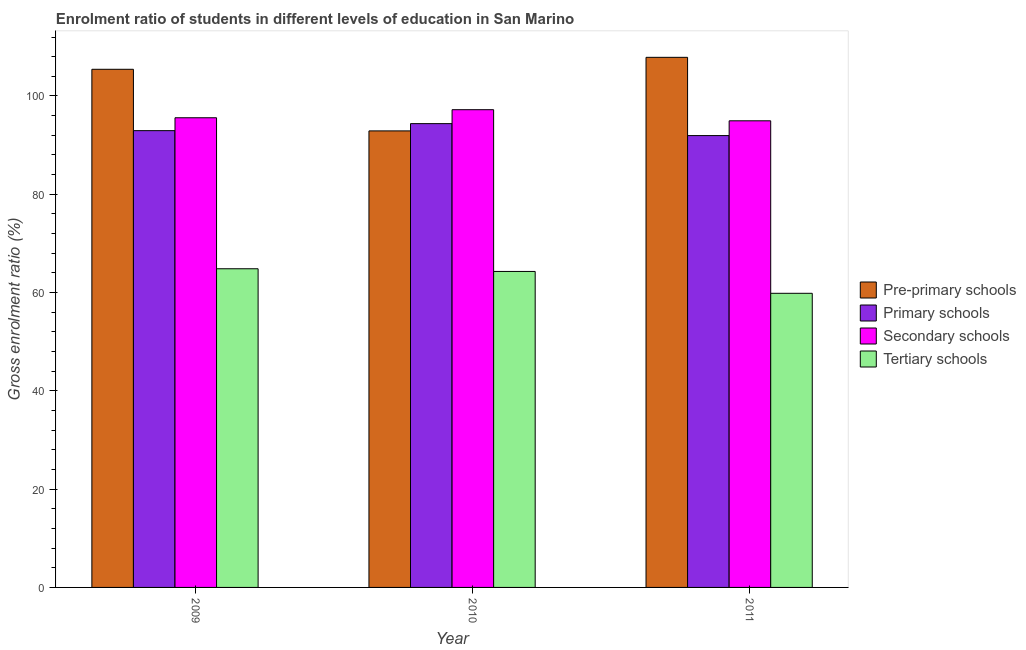How many different coloured bars are there?
Ensure brevity in your answer.  4. How many groups of bars are there?
Ensure brevity in your answer.  3. Are the number of bars per tick equal to the number of legend labels?
Offer a very short reply. Yes. Are the number of bars on each tick of the X-axis equal?
Keep it short and to the point. Yes. How many bars are there on the 2nd tick from the left?
Offer a very short reply. 4. How many bars are there on the 1st tick from the right?
Ensure brevity in your answer.  4. In how many cases, is the number of bars for a given year not equal to the number of legend labels?
Give a very brief answer. 0. What is the gross enrolment ratio in pre-primary schools in 2011?
Make the answer very short. 107.87. Across all years, what is the maximum gross enrolment ratio in tertiary schools?
Offer a terse response. 64.84. Across all years, what is the minimum gross enrolment ratio in primary schools?
Your answer should be very brief. 91.94. What is the total gross enrolment ratio in pre-primary schools in the graph?
Provide a succinct answer. 306.19. What is the difference between the gross enrolment ratio in tertiary schools in 2010 and that in 2011?
Your answer should be very brief. 4.45. What is the difference between the gross enrolment ratio in tertiary schools in 2009 and the gross enrolment ratio in primary schools in 2011?
Your answer should be very brief. 5. What is the average gross enrolment ratio in primary schools per year?
Give a very brief answer. 93.09. What is the ratio of the gross enrolment ratio in tertiary schools in 2010 to that in 2011?
Ensure brevity in your answer.  1.07. Is the difference between the gross enrolment ratio in pre-primary schools in 2009 and 2011 greater than the difference between the gross enrolment ratio in tertiary schools in 2009 and 2011?
Keep it short and to the point. No. What is the difference between the highest and the second highest gross enrolment ratio in pre-primary schools?
Make the answer very short. 2.43. What is the difference between the highest and the lowest gross enrolment ratio in secondary schools?
Your answer should be compact. 2.26. In how many years, is the gross enrolment ratio in pre-primary schools greater than the average gross enrolment ratio in pre-primary schools taken over all years?
Provide a short and direct response. 2. What does the 4th bar from the left in 2011 represents?
Provide a short and direct response. Tertiary schools. What does the 2nd bar from the right in 2011 represents?
Offer a very short reply. Secondary schools. How many bars are there?
Offer a terse response. 12. How many years are there in the graph?
Make the answer very short. 3. Are the values on the major ticks of Y-axis written in scientific E-notation?
Give a very brief answer. No. Where does the legend appear in the graph?
Ensure brevity in your answer.  Center right. What is the title of the graph?
Keep it short and to the point. Enrolment ratio of students in different levels of education in San Marino. Does "UNDP" appear as one of the legend labels in the graph?
Keep it short and to the point. No. What is the label or title of the Y-axis?
Your answer should be compact. Gross enrolment ratio (%). What is the Gross enrolment ratio (%) of Pre-primary schools in 2009?
Your answer should be very brief. 105.43. What is the Gross enrolment ratio (%) of Primary schools in 2009?
Provide a succinct answer. 92.95. What is the Gross enrolment ratio (%) of Secondary schools in 2009?
Ensure brevity in your answer.  95.57. What is the Gross enrolment ratio (%) of Tertiary schools in 2009?
Offer a very short reply. 64.84. What is the Gross enrolment ratio (%) in Pre-primary schools in 2010?
Your answer should be very brief. 92.9. What is the Gross enrolment ratio (%) in Primary schools in 2010?
Provide a succinct answer. 94.37. What is the Gross enrolment ratio (%) in Secondary schools in 2010?
Provide a succinct answer. 97.21. What is the Gross enrolment ratio (%) of Tertiary schools in 2010?
Your answer should be compact. 64.3. What is the Gross enrolment ratio (%) of Pre-primary schools in 2011?
Provide a short and direct response. 107.87. What is the Gross enrolment ratio (%) in Primary schools in 2011?
Provide a short and direct response. 91.94. What is the Gross enrolment ratio (%) of Secondary schools in 2011?
Provide a succinct answer. 94.95. What is the Gross enrolment ratio (%) in Tertiary schools in 2011?
Keep it short and to the point. 59.85. Across all years, what is the maximum Gross enrolment ratio (%) in Pre-primary schools?
Your response must be concise. 107.87. Across all years, what is the maximum Gross enrolment ratio (%) of Primary schools?
Provide a succinct answer. 94.37. Across all years, what is the maximum Gross enrolment ratio (%) in Secondary schools?
Your answer should be compact. 97.21. Across all years, what is the maximum Gross enrolment ratio (%) in Tertiary schools?
Provide a succinct answer. 64.84. Across all years, what is the minimum Gross enrolment ratio (%) of Pre-primary schools?
Provide a succinct answer. 92.9. Across all years, what is the minimum Gross enrolment ratio (%) in Primary schools?
Your answer should be compact. 91.94. Across all years, what is the minimum Gross enrolment ratio (%) of Secondary schools?
Provide a succinct answer. 94.95. Across all years, what is the minimum Gross enrolment ratio (%) of Tertiary schools?
Keep it short and to the point. 59.85. What is the total Gross enrolment ratio (%) of Pre-primary schools in the graph?
Ensure brevity in your answer.  306.19. What is the total Gross enrolment ratio (%) of Primary schools in the graph?
Provide a succinct answer. 279.26. What is the total Gross enrolment ratio (%) in Secondary schools in the graph?
Offer a terse response. 287.73. What is the total Gross enrolment ratio (%) of Tertiary schools in the graph?
Offer a very short reply. 188.99. What is the difference between the Gross enrolment ratio (%) in Pre-primary schools in 2009 and that in 2010?
Offer a very short reply. 12.54. What is the difference between the Gross enrolment ratio (%) in Primary schools in 2009 and that in 2010?
Your answer should be very brief. -1.43. What is the difference between the Gross enrolment ratio (%) of Secondary schools in 2009 and that in 2010?
Ensure brevity in your answer.  -1.64. What is the difference between the Gross enrolment ratio (%) of Tertiary schools in 2009 and that in 2010?
Your answer should be compact. 0.55. What is the difference between the Gross enrolment ratio (%) in Pre-primary schools in 2009 and that in 2011?
Your response must be concise. -2.43. What is the difference between the Gross enrolment ratio (%) in Secondary schools in 2009 and that in 2011?
Your answer should be very brief. 0.62. What is the difference between the Gross enrolment ratio (%) in Tertiary schools in 2009 and that in 2011?
Your answer should be compact. 5. What is the difference between the Gross enrolment ratio (%) of Pre-primary schools in 2010 and that in 2011?
Provide a short and direct response. -14.97. What is the difference between the Gross enrolment ratio (%) in Primary schools in 2010 and that in 2011?
Offer a terse response. 2.43. What is the difference between the Gross enrolment ratio (%) in Secondary schools in 2010 and that in 2011?
Give a very brief answer. 2.26. What is the difference between the Gross enrolment ratio (%) in Tertiary schools in 2010 and that in 2011?
Make the answer very short. 4.45. What is the difference between the Gross enrolment ratio (%) of Pre-primary schools in 2009 and the Gross enrolment ratio (%) of Primary schools in 2010?
Your answer should be very brief. 11.06. What is the difference between the Gross enrolment ratio (%) of Pre-primary schools in 2009 and the Gross enrolment ratio (%) of Secondary schools in 2010?
Keep it short and to the point. 8.22. What is the difference between the Gross enrolment ratio (%) in Pre-primary schools in 2009 and the Gross enrolment ratio (%) in Tertiary schools in 2010?
Provide a succinct answer. 41.14. What is the difference between the Gross enrolment ratio (%) of Primary schools in 2009 and the Gross enrolment ratio (%) of Secondary schools in 2010?
Your answer should be very brief. -4.26. What is the difference between the Gross enrolment ratio (%) of Primary schools in 2009 and the Gross enrolment ratio (%) of Tertiary schools in 2010?
Offer a terse response. 28.65. What is the difference between the Gross enrolment ratio (%) of Secondary schools in 2009 and the Gross enrolment ratio (%) of Tertiary schools in 2010?
Give a very brief answer. 31.27. What is the difference between the Gross enrolment ratio (%) of Pre-primary schools in 2009 and the Gross enrolment ratio (%) of Primary schools in 2011?
Ensure brevity in your answer.  13.49. What is the difference between the Gross enrolment ratio (%) in Pre-primary schools in 2009 and the Gross enrolment ratio (%) in Secondary schools in 2011?
Your response must be concise. 10.48. What is the difference between the Gross enrolment ratio (%) of Pre-primary schools in 2009 and the Gross enrolment ratio (%) of Tertiary schools in 2011?
Provide a short and direct response. 45.58. What is the difference between the Gross enrolment ratio (%) in Primary schools in 2009 and the Gross enrolment ratio (%) in Secondary schools in 2011?
Provide a succinct answer. -2. What is the difference between the Gross enrolment ratio (%) in Primary schools in 2009 and the Gross enrolment ratio (%) in Tertiary schools in 2011?
Make the answer very short. 33.1. What is the difference between the Gross enrolment ratio (%) in Secondary schools in 2009 and the Gross enrolment ratio (%) in Tertiary schools in 2011?
Give a very brief answer. 35.72. What is the difference between the Gross enrolment ratio (%) in Pre-primary schools in 2010 and the Gross enrolment ratio (%) in Primary schools in 2011?
Keep it short and to the point. 0.95. What is the difference between the Gross enrolment ratio (%) of Pre-primary schools in 2010 and the Gross enrolment ratio (%) of Secondary schools in 2011?
Make the answer very short. -2.05. What is the difference between the Gross enrolment ratio (%) of Pre-primary schools in 2010 and the Gross enrolment ratio (%) of Tertiary schools in 2011?
Give a very brief answer. 33.05. What is the difference between the Gross enrolment ratio (%) of Primary schools in 2010 and the Gross enrolment ratio (%) of Secondary schools in 2011?
Offer a terse response. -0.57. What is the difference between the Gross enrolment ratio (%) of Primary schools in 2010 and the Gross enrolment ratio (%) of Tertiary schools in 2011?
Offer a very short reply. 34.53. What is the difference between the Gross enrolment ratio (%) in Secondary schools in 2010 and the Gross enrolment ratio (%) in Tertiary schools in 2011?
Offer a very short reply. 37.36. What is the average Gross enrolment ratio (%) in Pre-primary schools per year?
Provide a short and direct response. 102.06. What is the average Gross enrolment ratio (%) of Primary schools per year?
Ensure brevity in your answer.  93.09. What is the average Gross enrolment ratio (%) in Secondary schools per year?
Provide a short and direct response. 95.91. What is the average Gross enrolment ratio (%) in Tertiary schools per year?
Make the answer very short. 63. In the year 2009, what is the difference between the Gross enrolment ratio (%) in Pre-primary schools and Gross enrolment ratio (%) in Primary schools?
Keep it short and to the point. 12.49. In the year 2009, what is the difference between the Gross enrolment ratio (%) of Pre-primary schools and Gross enrolment ratio (%) of Secondary schools?
Your answer should be very brief. 9.86. In the year 2009, what is the difference between the Gross enrolment ratio (%) in Pre-primary schools and Gross enrolment ratio (%) in Tertiary schools?
Your answer should be very brief. 40.59. In the year 2009, what is the difference between the Gross enrolment ratio (%) in Primary schools and Gross enrolment ratio (%) in Secondary schools?
Make the answer very short. -2.62. In the year 2009, what is the difference between the Gross enrolment ratio (%) in Primary schools and Gross enrolment ratio (%) in Tertiary schools?
Keep it short and to the point. 28.1. In the year 2009, what is the difference between the Gross enrolment ratio (%) of Secondary schools and Gross enrolment ratio (%) of Tertiary schools?
Keep it short and to the point. 30.72. In the year 2010, what is the difference between the Gross enrolment ratio (%) of Pre-primary schools and Gross enrolment ratio (%) of Primary schools?
Keep it short and to the point. -1.48. In the year 2010, what is the difference between the Gross enrolment ratio (%) in Pre-primary schools and Gross enrolment ratio (%) in Secondary schools?
Keep it short and to the point. -4.31. In the year 2010, what is the difference between the Gross enrolment ratio (%) in Pre-primary schools and Gross enrolment ratio (%) in Tertiary schools?
Your response must be concise. 28.6. In the year 2010, what is the difference between the Gross enrolment ratio (%) of Primary schools and Gross enrolment ratio (%) of Secondary schools?
Ensure brevity in your answer.  -2.83. In the year 2010, what is the difference between the Gross enrolment ratio (%) of Primary schools and Gross enrolment ratio (%) of Tertiary schools?
Keep it short and to the point. 30.08. In the year 2010, what is the difference between the Gross enrolment ratio (%) of Secondary schools and Gross enrolment ratio (%) of Tertiary schools?
Your response must be concise. 32.91. In the year 2011, what is the difference between the Gross enrolment ratio (%) in Pre-primary schools and Gross enrolment ratio (%) in Primary schools?
Keep it short and to the point. 15.92. In the year 2011, what is the difference between the Gross enrolment ratio (%) in Pre-primary schools and Gross enrolment ratio (%) in Secondary schools?
Your answer should be very brief. 12.92. In the year 2011, what is the difference between the Gross enrolment ratio (%) of Pre-primary schools and Gross enrolment ratio (%) of Tertiary schools?
Your answer should be very brief. 48.02. In the year 2011, what is the difference between the Gross enrolment ratio (%) in Primary schools and Gross enrolment ratio (%) in Secondary schools?
Your response must be concise. -3.01. In the year 2011, what is the difference between the Gross enrolment ratio (%) in Primary schools and Gross enrolment ratio (%) in Tertiary schools?
Provide a short and direct response. 32.09. In the year 2011, what is the difference between the Gross enrolment ratio (%) of Secondary schools and Gross enrolment ratio (%) of Tertiary schools?
Your answer should be compact. 35.1. What is the ratio of the Gross enrolment ratio (%) of Pre-primary schools in 2009 to that in 2010?
Keep it short and to the point. 1.14. What is the ratio of the Gross enrolment ratio (%) of Primary schools in 2009 to that in 2010?
Ensure brevity in your answer.  0.98. What is the ratio of the Gross enrolment ratio (%) in Secondary schools in 2009 to that in 2010?
Your answer should be very brief. 0.98. What is the ratio of the Gross enrolment ratio (%) in Tertiary schools in 2009 to that in 2010?
Offer a very short reply. 1.01. What is the ratio of the Gross enrolment ratio (%) of Pre-primary schools in 2009 to that in 2011?
Ensure brevity in your answer.  0.98. What is the ratio of the Gross enrolment ratio (%) in Primary schools in 2009 to that in 2011?
Your answer should be very brief. 1.01. What is the ratio of the Gross enrolment ratio (%) of Secondary schools in 2009 to that in 2011?
Ensure brevity in your answer.  1.01. What is the ratio of the Gross enrolment ratio (%) in Tertiary schools in 2009 to that in 2011?
Keep it short and to the point. 1.08. What is the ratio of the Gross enrolment ratio (%) of Pre-primary schools in 2010 to that in 2011?
Offer a terse response. 0.86. What is the ratio of the Gross enrolment ratio (%) of Primary schools in 2010 to that in 2011?
Ensure brevity in your answer.  1.03. What is the ratio of the Gross enrolment ratio (%) of Secondary schools in 2010 to that in 2011?
Offer a very short reply. 1.02. What is the ratio of the Gross enrolment ratio (%) of Tertiary schools in 2010 to that in 2011?
Provide a succinct answer. 1.07. What is the difference between the highest and the second highest Gross enrolment ratio (%) of Pre-primary schools?
Ensure brevity in your answer.  2.43. What is the difference between the highest and the second highest Gross enrolment ratio (%) in Primary schools?
Provide a succinct answer. 1.43. What is the difference between the highest and the second highest Gross enrolment ratio (%) in Secondary schools?
Ensure brevity in your answer.  1.64. What is the difference between the highest and the second highest Gross enrolment ratio (%) in Tertiary schools?
Offer a very short reply. 0.55. What is the difference between the highest and the lowest Gross enrolment ratio (%) in Pre-primary schools?
Ensure brevity in your answer.  14.97. What is the difference between the highest and the lowest Gross enrolment ratio (%) in Primary schools?
Provide a succinct answer. 2.43. What is the difference between the highest and the lowest Gross enrolment ratio (%) of Secondary schools?
Keep it short and to the point. 2.26. What is the difference between the highest and the lowest Gross enrolment ratio (%) in Tertiary schools?
Provide a succinct answer. 5. 